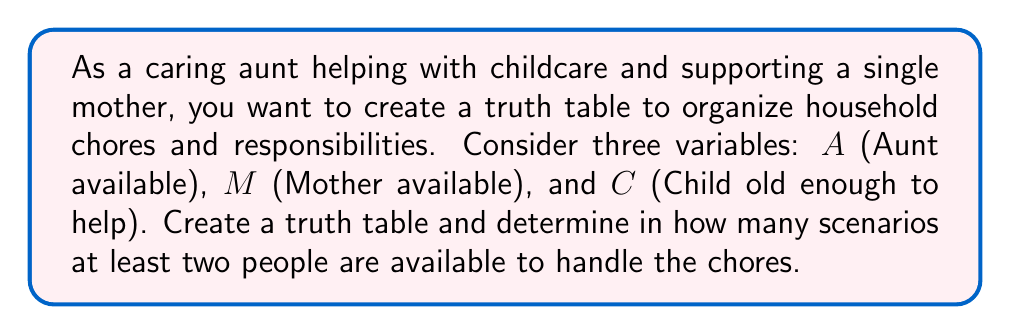Help me with this question. Let's approach this step-by-step:

1) First, we need to create a truth table with three variables: A, M, and C.

2) The truth table will have $2^3 = 8$ rows, representing all possible combinations:

   $$
   \begin{array}{|c|c|c|c|}
   \hline
   A & M & C & \text{At least 2 available} \\
   \hline
   0 & 0 & 0 & 0 \\
   0 & 0 & 1 & 0 \\
   0 & 1 & 0 & 0 \\
   0 & 1 & 1 & 1 \\
   1 & 0 & 0 & 0 \\
   1 & 0 & 1 & 1 \\
   1 & 1 & 0 & 1 \\
   1 & 1 & 1 & 1 \\
   \hline
   \end{array}
   $$

3) In the last column, we put 1 if at least two people are available (i.e., if at least two of A, M, and C are 1), and 0 otherwise.

4) The Boolean expression for "at least two available" can be written as:
   
   $$(A \land M) \lor (A \land C) \lor (M \land C)$$

5) To count the number of scenarios where at least two people are available, we count the number of 1's in the last column of the truth table.

6) There are four rows where the last column is 1, corresponding to the scenarios:
   - Aunt and Mother available (Child not)
   - Aunt and Child available (Mother not)
   - Mother and Child available (Aunt not)
   - All three available
Answer: 4 scenarios 